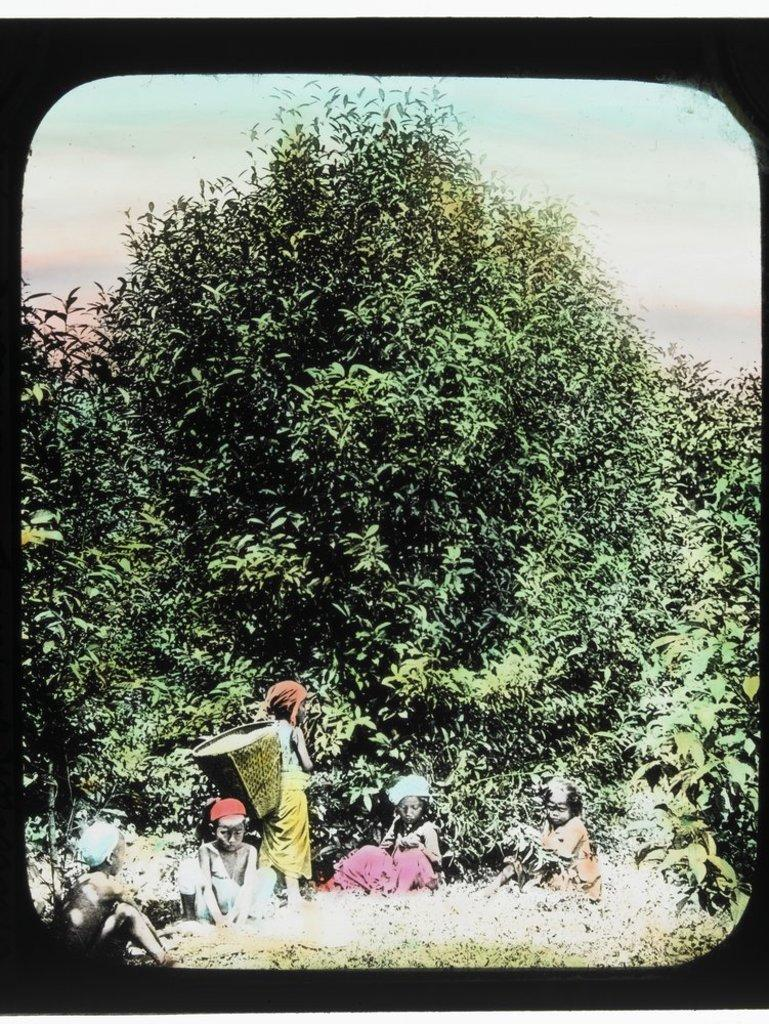Who or what can be seen in the image? There are people in the image. What is visible in the background of the image? There is a sky visible in the image. What type of vegetation is present in the image? There are plants and a tree in the image. What type of poison can be seen in the image? There is no poison present in the image. What is the position of the tree in relation to the people? The position of the tree in relation to the people cannot be determined from the image alone, as there is no reference point provided. 